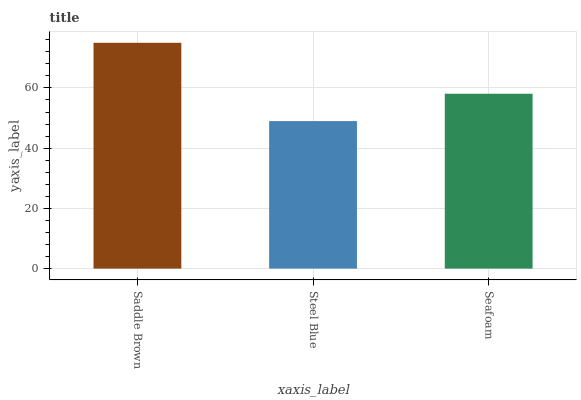Is Seafoam the minimum?
Answer yes or no. No. Is Seafoam the maximum?
Answer yes or no. No. Is Seafoam greater than Steel Blue?
Answer yes or no. Yes. Is Steel Blue less than Seafoam?
Answer yes or no. Yes. Is Steel Blue greater than Seafoam?
Answer yes or no. No. Is Seafoam less than Steel Blue?
Answer yes or no. No. Is Seafoam the high median?
Answer yes or no. Yes. Is Seafoam the low median?
Answer yes or no. Yes. Is Saddle Brown the high median?
Answer yes or no. No. Is Steel Blue the low median?
Answer yes or no. No. 